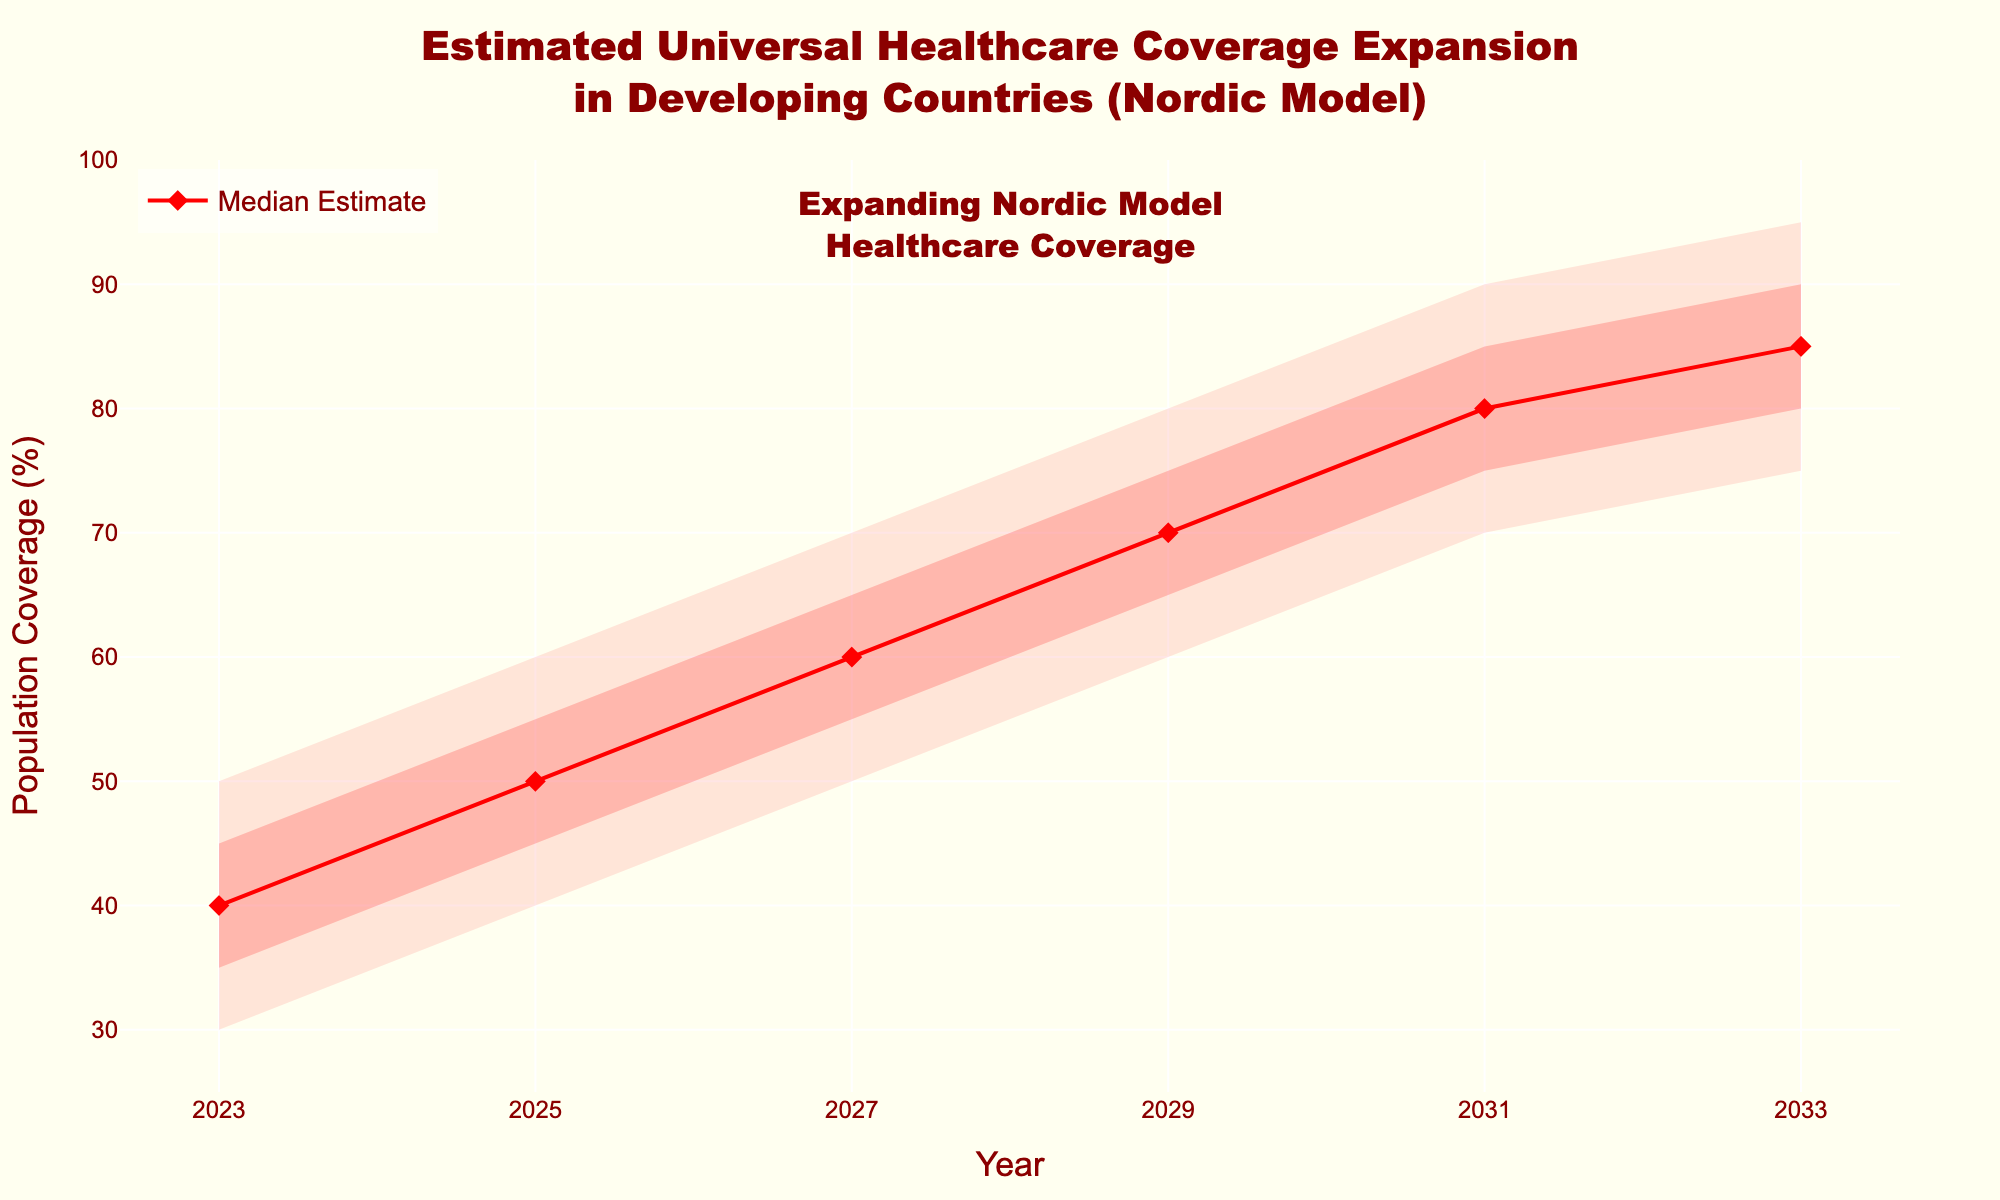What's the title of the fan chart? The title of the chart is prominently displayed at the top of the figure in a large, dark red font. Reading the text clearly provides the title.
Answer: Estimated Universal Healthcare Coverage Expansion in Developing Countries (Nordic Model) How many years are represented in the chart? The x-axis shows the years as markers, starting from 2023 and increasing by intervals of 2 years until 2033.
Answer: 6 What is the median estimate of coverage in 2029? Locate the line labeled "Median Estimate," trace it to the year 2029 along the x-axis, and read the corresponding y-axis value.
Answer: 70% Which year shows the smallest range between the lower and upper bounds? Calculate the range by subtracting the lower bound from the upper bound for each year. The smallest difference indicates the year with the smallest range.
Answer: 2033 What is the difference between the high estimate and low estimate in 2025? The high estimate for 2025 is 55%, and the low estimate is 45%. Subtract the low estimate from the high estimate to find the difference.
Answer: 10% Which year is expected to have at least 60% median coverage based on the estimates? Locate the line for the "Median Estimate" and find the first year where the coverage reaches or exceeds 60%.
Answer: 2027 How does the median estimate coverage change from 2027 to 2031? Find the median estimate values for 2027 and 2031 and calculate the difference (80% - 60%).
Answer: 20% increase In what year do the upper and lower bounds suggest the widest range of coverage? Compare the upper and lower bounds for each year and identify where the difference between them is the largest.
Answer: 2023 What population coverage does the upper bound predict for 2031? Look at the "Upper Bound" values and find the corresponding value for the year 2031.
Answer: 90% Which year does the annotation "Expanding Nordic Model Healthcare Coverage" relate to in the chart? The annotation is placed near the center of the chart and aligned with the year represented directly below it.
Answer: 2028 